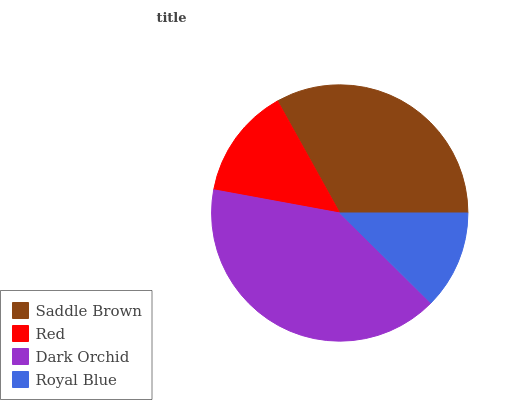Is Royal Blue the minimum?
Answer yes or no. Yes. Is Dark Orchid the maximum?
Answer yes or no. Yes. Is Red the minimum?
Answer yes or no. No. Is Red the maximum?
Answer yes or no. No. Is Saddle Brown greater than Red?
Answer yes or no. Yes. Is Red less than Saddle Brown?
Answer yes or no. Yes. Is Red greater than Saddle Brown?
Answer yes or no. No. Is Saddle Brown less than Red?
Answer yes or no. No. Is Saddle Brown the high median?
Answer yes or no. Yes. Is Red the low median?
Answer yes or no. Yes. Is Royal Blue the high median?
Answer yes or no. No. Is Saddle Brown the low median?
Answer yes or no. No. 